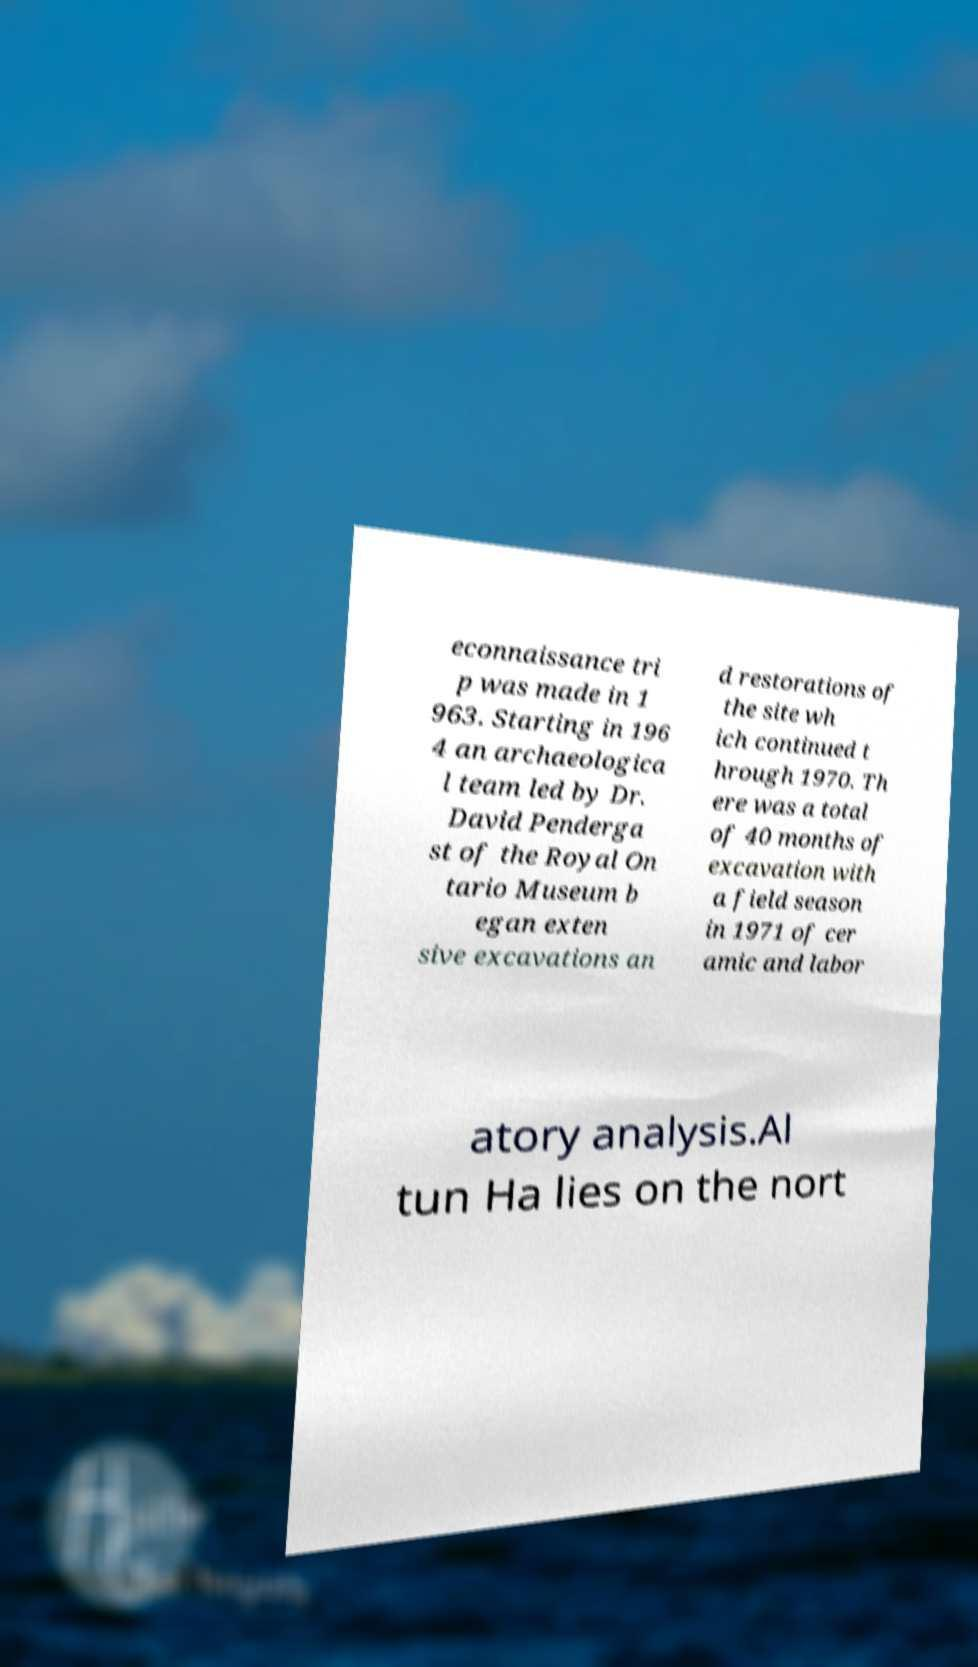Please read and relay the text visible in this image. What does it say? econnaissance tri p was made in 1 963. Starting in 196 4 an archaeologica l team led by Dr. David Penderga st of the Royal On tario Museum b egan exten sive excavations an d restorations of the site wh ich continued t hrough 1970. Th ere was a total of 40 months of excavation with a field season in 1971 of cer amic and labor atory analysis.Al tun Ha lies on the nort 